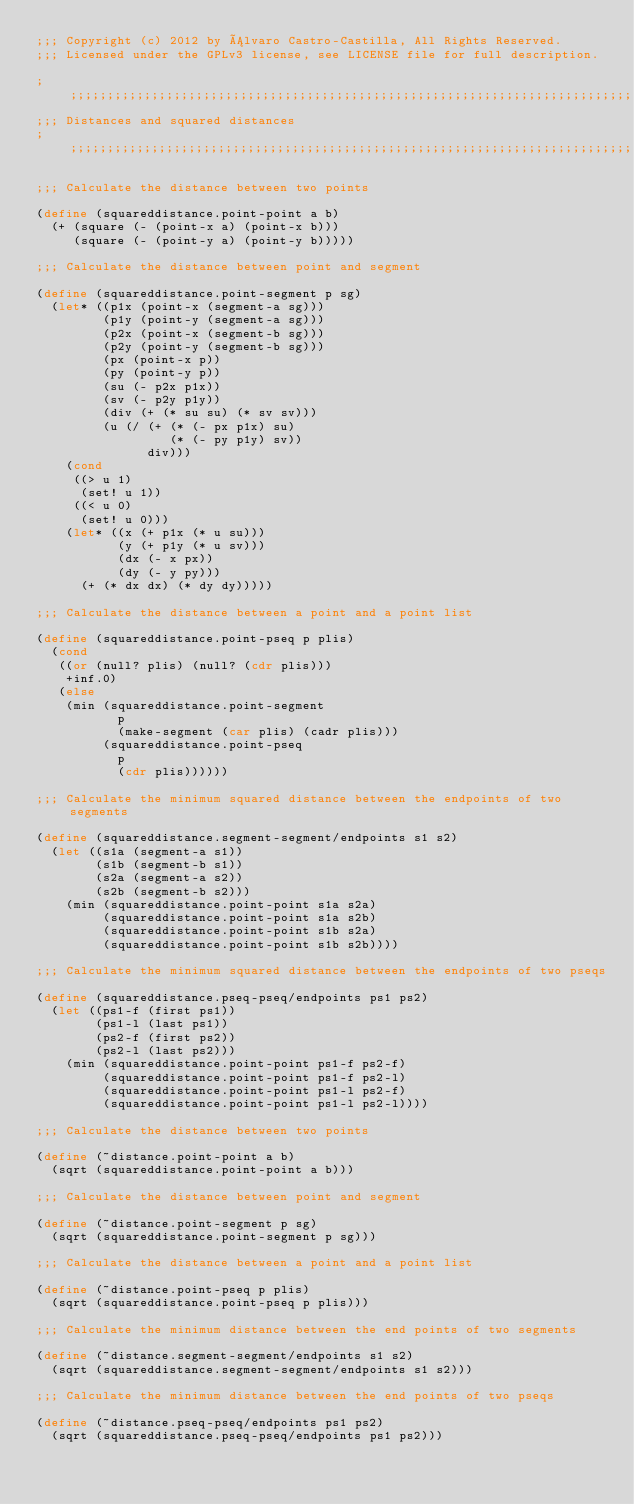<code> <loc_0><loc_0><loc_500><loc_500><_Scheme_>;;; Copyright (c) 2012 by Álvaro Castro-Castilla, All Rights Reserved.
;;; Licensed under the GPLv3 license, see LICENSE file for full description.

;;;;;;;;;;;;;;;;;;;;;;;;;;;;;;;;;;;;;;;;;;;;;;;;;;;;;;;;;;;;;;;;;;;;;;;;;;;;;;;
;;; Distances and squared distances
;;;;;;;;;;;;;;;;;;;;;;;;;;;;;;;;;;;;;;;;;;;;;;;;;;;;;;;;;;;;;;;;;;;;;;;;;;;;;;;

;;; Calculate the distance between two points

(define (squareddistance.point-point a b)
  (+ (square (- (point-x a) (point-x b)))
     (square (- (point-y a) (point-y b)))))

;;; Calculate the distance between point and segment

(define (squareddistance.point-segment p sg)
  (let* ((p1x (point-x (segment-a sg)))
         (p1y (point-y (segment-a sg)))
         (p2x (point-x (segment-b sg)))
         (p2y (point-y (segment-b sg)))
         (px (point-x p))
         (py (point-y p))
         (su (- p2x p1x))
         (sv (- p2y p1y))
         (div (+ (* su su) (* sv sv)))
         (u (/ (+ (* (- px p1x) su)
                  (* (- py p1y) sv))
               div)))
    (cond
     ((> u 1)
      (set! u 1))
     ((< u 0)
      (set! u 0)))
    (let* ((x (+ p1x (* u su)))
           (y (+ p1y (* u sv)))
           (dx (- x px))
           (dy (- y py)))
      (+ (* dx dx) (* dy dy)))))

;;; Calculate the distance between a point and a point list

(define (squareddistance.point-pseq p plis)
  (cond
   ((or (null? plis) (null? (cdr plis)))
    +inf.0)
   (else
    (min (squareddistance.point-segment
           p
           (make-segment (car plis) (cadr plis)))
         (squareddistance.point-pseq
           p
           (cdr plis))))))

;;; Calculate the minimum squared distance between the endpoints of two segments

(define (squareddistance.segment-segment/endpoints s1 s2)
  (let ((s1a (segment-a s1))
        (s1b (segment-b s1))
        (s2a (segment-a s2))
        (s2b (segment-b s2)))
    (min (squareddistance.point-point s1a s2a)
         (squareddistance.point-point s1a s2b)
         (squareddistance.point-point s1b s2a)
         (squareddistance.point-point s1b s2b))))

;;; Calculate the minimum squared distance between the endpoints of two pseqs

(define (squareddistance.pseq-pseq/endpoints ps1 ps2)
  (let ((ps1-f (first ps1))
        (ps1-l (last ps1))
        (ps2-f (first ps2))
        (ps2-l (last ps2)))
    (min (squareddistance.point-point ps1-f ps2-f)
         (squareddistance.point-point ps1-f ps2-l)
         (squareddistance.point-point ps1-l ps2-f)
         (squareddistance.point-point ps1-l ps2-l))))

;;; Calculate the distance between two points

(define (~distance.point-point a b)
  (sqrt (squareddistance.point-point a b)))

;;; Calculate the distance between point and segment

(define (~distance.point-segment p sg)
  (sqrt (squareddistance.point-segment p sg)))

;;; Calculate the distance between a point and a point list

(define (~distance.point-pseq p plis)
  (sqrt (squareddistance.point-pseq p plis)))

;;; Calculate the minimum distance between the end points of two segments

(define (~distance.segment-segment/endpoints s1 s2)
  (sqrt (squareddistance.segment-segment/endpoints s1 s2)))

;;; Calculate the minimum distance between the end points of two pseqs

(define (~distance.pseq-pseq/endpoints ps1 ps2)
  (sqrt (squareddistance.pseq-pseq/endpoints ps1 ps2)))

</code> 